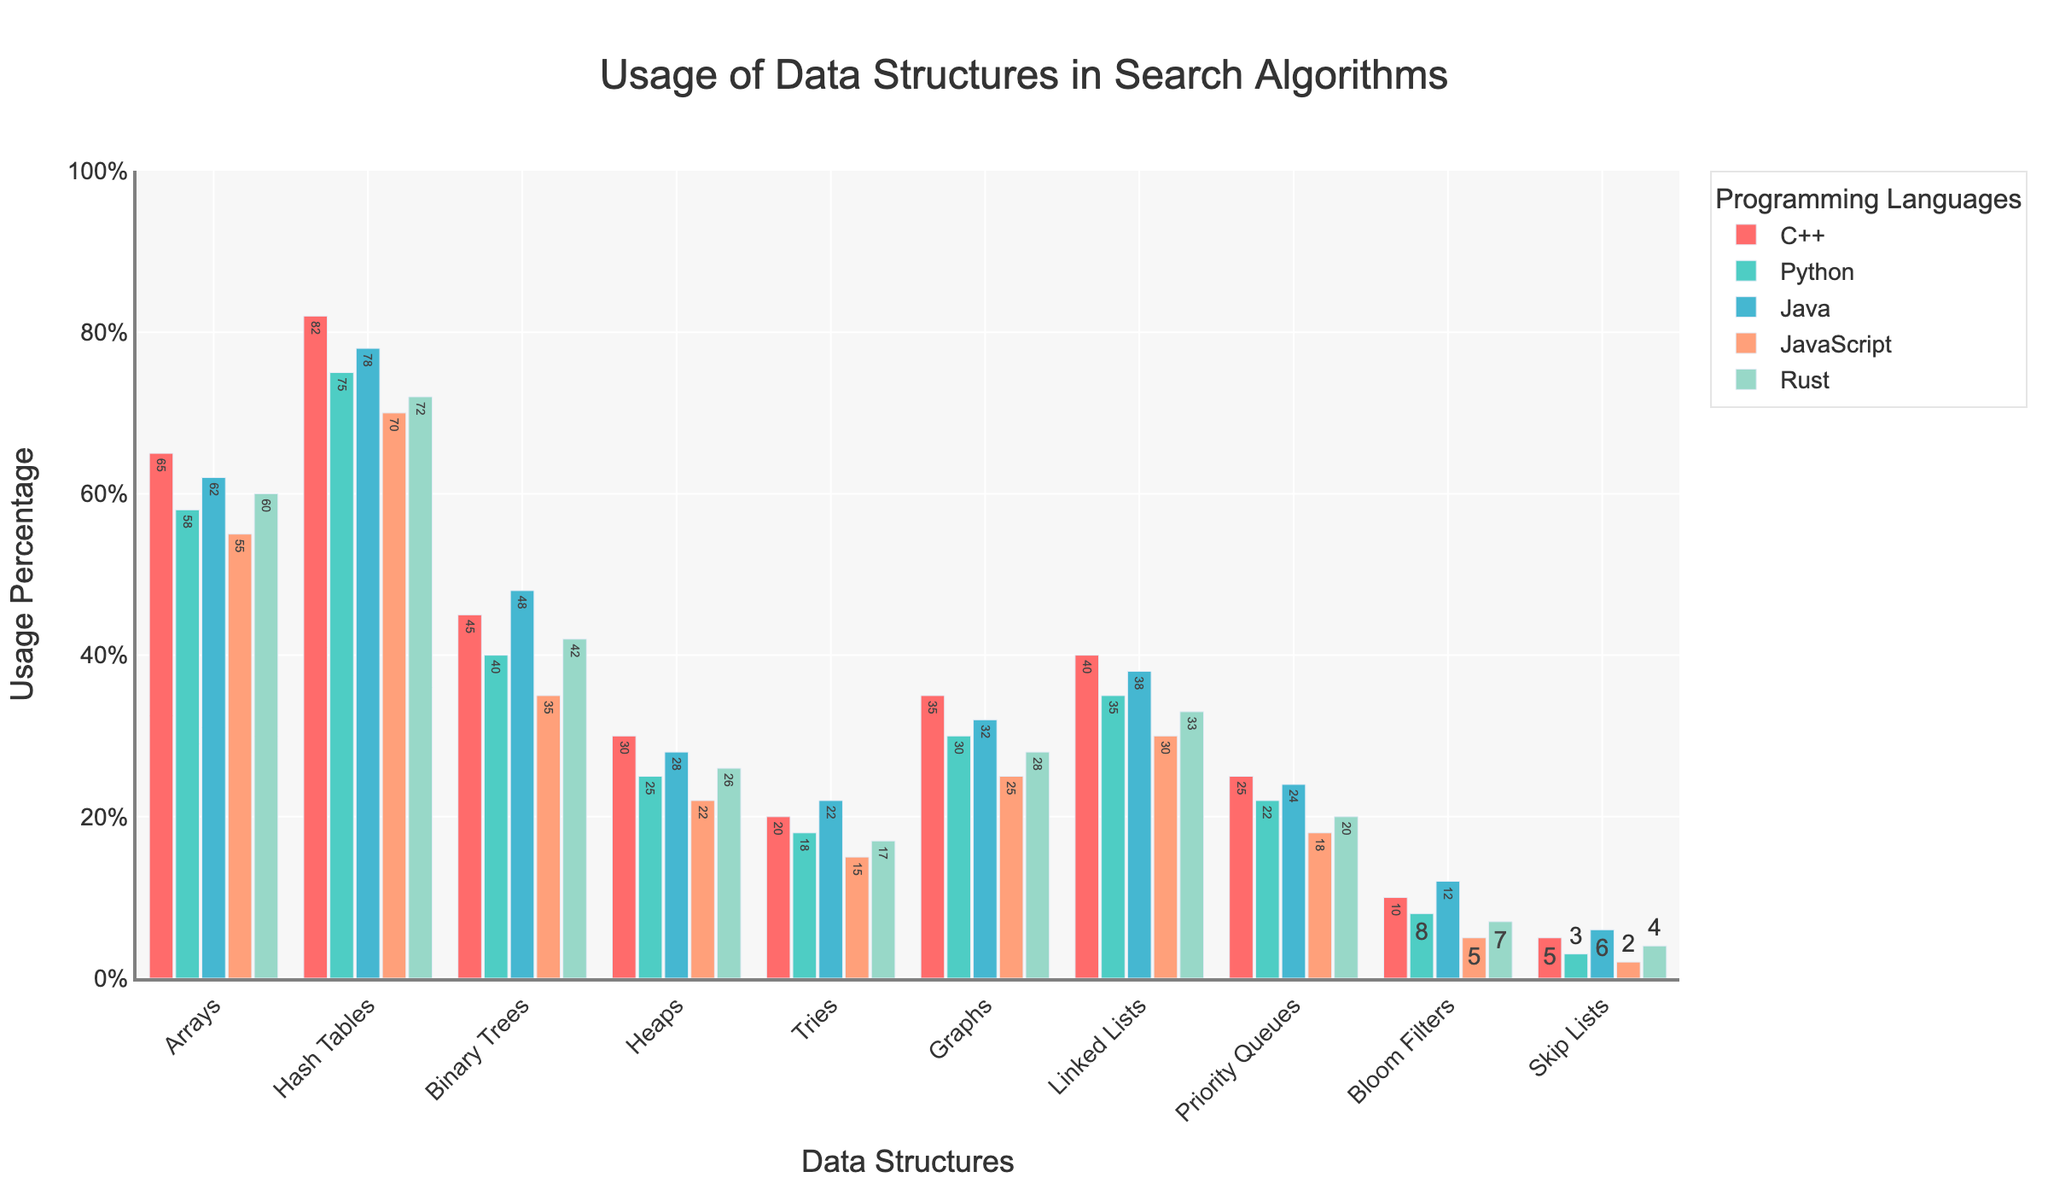What's the most commonly used data structure in Python for search algorithms? By visually inspecting the different heights of the bars for Python, the tallest bar represents Hash Tables.
Answer: Hash Tables Which programming language has the highest usage percentage for Tries? Comparing the heights of the Tries bars across all programming languages, Java has the tallest bar.
Answer: Java How does the usage of Heaps in C++ compare to JavaScript? The height of the Heaps bar for C++ is higher than the bar for JavaScript. This indicates that Heaps are used more in C++ than in JavaScript.
Answer: C++ has higher usage What is the sum of usage percentages for Graphs and Linked Lists in Rust? Adding the percentage values for Graphs (28) and Linked Lists (33) in Rust gives: 28 + 33 = 61.
Answer: 61 What's the difference in usage percentage of Hash Tables between Python and JavaScript? The usage percentage of Hash Tables in Python is 75, and in JavaScript, it is 70. Subtracting these values gives: 75 - 70 = 5.
Answer: 5 What is the average usage of Binary Trees across all programming languages? Adding the usage percentages of Binary Trees across all languages: 45 (C++) + 40 (Python) + 48 (Java) + 35 (JavaScript) + 42 (Rust) = 210, and dividing by the number of languages (5) gives: 210 / 5 = 42.
Answer: 42 Compare the usage of Arrays in C++ and Rust. Which one is higher and by how much? The usage percentage of Arrays in C++ is 65, while in Rust, it is 60. Subtracting these values gives: 65 - 60 = 5, with C++ being higher.
Answer: C++ by 5 What is the median usage percentage of Skip Lists across all languages? The Skip Lists usage percentages are 5 (C++), 3 (Python), 6 (Java), 2 (JavaScript), and 4 (Rust). Sorting these values gives 2, 3, 4, 5, 6. The median is the middle value: 4.
Answer: 4 Which data structure has the least usage across all programming languages? By comparing the height of all bars for each data structure, Skip Lists have the shortest bars on average, indicating they are the least used.
Answer: Skip Lists Is the usage of Bloom Filters in JavaScript higher or lower than in Python? By visually comparing the height of the Bloom Filters bar for JavaScript (5) with Python (8), it is clear that JavaScript has a lower usage.
Answer: Lower 